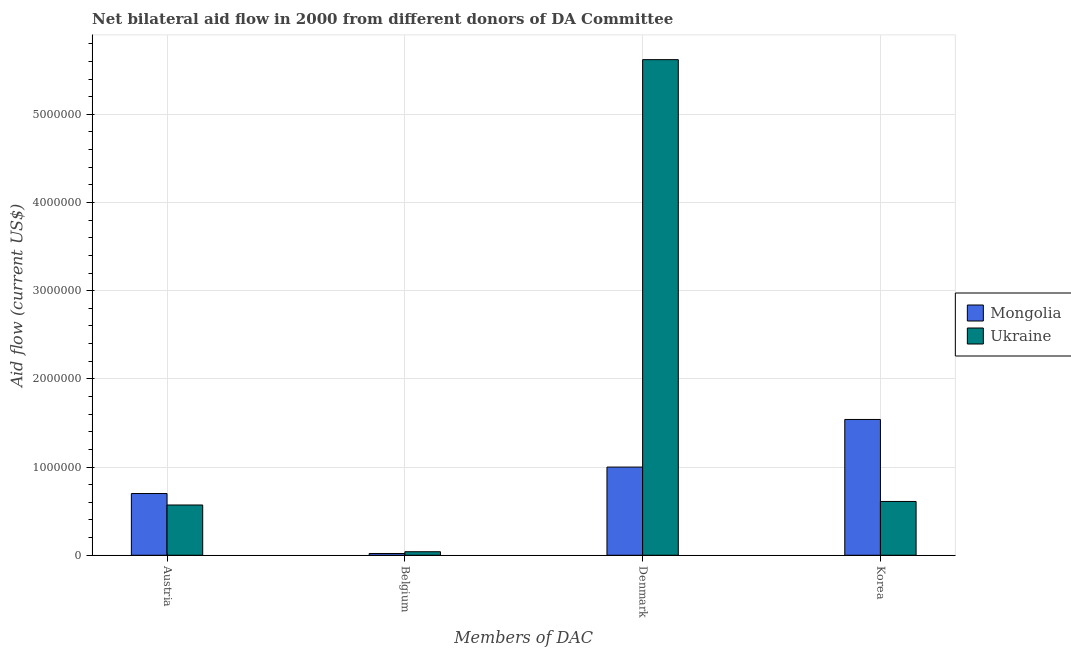Are the number of bars per tick equal to the number of legend labels?
Provide a short and direct response. Yes. How many bars are there on the 2nd tick from the left?
Your answer should be very brief. 2. How many bars are there on the 1st tick from the right?
Keep it short and to the point. 2. What is the amount of aid given by belgium in Mongolia?
Provide a short and direct response. 2.00e+04. Across all countries, what is the maximum amount of aid given by korea?
Offer a terse response. 1.54e+06. Across all countries, what is the minimum amount of aid given by austria?
Your answer should be compact. 5.70e+05. In which country was the amount of aid given by korea maximum?
Make the answer very short. Mongolia. In which country was the amount of aid given by austria minimum?
Ensure brevity in your answer.  Ukraine. What is the total amount of aid given by belgium in the graph?
Provide a succinct answer. 6.00e+04. What is the difference between the amount of aid given by denmark in Mongolia and that in Ukraine?
Provide a short and direct response. -4.62e+06. What is the difference between the amount of aid given by denmark in Ukraine and the amount of aid given by belgium in Mongolia?
Your answer should be very brief. 5.60e+06. What is the average amount of aid given by belgium per country?
Provide a short and direct response. 3.00e+04. What is the difference between the amount of aid given by denmark and amount of aid given by belgium in Ukraine?
Make the answer very short. 5.58e+06. What is the ratio of the amount of aid given by korea in Mongolia to that in Ukraine?
Your answer should be very brief. 2.52. Is the amount of aid given by belgium in Ukraine less than that in Mongolia?
Provide a succinct answer. No. What is the difference between the highest and the second highest amount of aid given by austria?
Make the answer very short. 1.30e+05. What is the difference between the highest and the lowest amount of aid given by korea?
Keep it short and to the point. 9.30e+05. Is it the case that in every country, the sum of the amount of aid given by denmark and amount of aid given by austria is greater than the sum of amount of aid given by belgium and amount of aid given by korea?
Provide a succinct answer. No. What does the 2nd bar from the left in Denmark represents?
Your answer should be compact. Ukraine. What does the 1st bar from the right in Denmark represents?
Your answer should be very brief. Ukraine. Are all the bars in the graph horizontal?
Make the answer very short. No. What is the difference between two consecutive major ticks on the Y-axis?
Your answer should be very brief. 1.00e+06. Are the values on the major ticks of Y-axis written in scientific E-notation?
Provide a succinct answer. No. Does the graph contain any zero values?
Your answer should be very brief. No. How many legend labels are there?
Your answer should be very brief. 2. What is the title of the graph?
Your answer should be compact. Net bilateral aid flow in 2000 from different donors of DA Committee. Does "Nepal" appear as one of the legend labels in the graph?
Your answer should be very brief. No. What is the label or title of the X-axis?
Provide a short and direct response. Members of DAC. What is the label or title of the Y-axis?
Provide a short and direct response. Aid flow (current US$). What is the Aid flow (current US$) of Mongolia in Austria?
Your answer should be very brief. 7.00e+05. What is the Aid flow (current US$) in Ukraine in Austria?
Provide a succinct answer. 5.70e+05. What is the Aid flow (current US$) of Ukraine in Belgium?
Offer a terse response. 4.00e+04. What is the Aid flow (current US$) in Mongolia in Denmark?
Offer a terse response. 1.00e+06. What is the Aid flow (current US$) of Ukraine in Denmark?
Provide a short and direct response. 5.62e+06. What is the Aid flow (current US$) of Mongolia in Korea?
Give a very brief answer. 1.54e+06. Across all Members of DAC, what is the maximum Aid flow (current US$) in Mongolia?
Your answer should be compact. 1.54e+06. Across all Members of DAC, what is the maximum Aid flow (current US$) of Ukraine?
Your response must be concise. 5.62e+06. Across all Members of DAC, what is the minimum Aid flow (current US$) of Ukraine?
Provide a short and direct response. 4.00e+04. What is the total Aid flow (current US$) in Mongolia in the graph?
Give a very brief answer. 3.26e+06. What is the total Aid flow (current US$) in Ukraine in the graph?
Give a very brief answer. 6.84e+06. What is the difference between the Aid flow (current US$) in Mongolia in Austria and that in Belgium?
Your answer should be compact. 6.80e+05. What is the difference between the Aid flow (current US$) of Ukraine in Austria and that in Belgium?
Provide a short and direct response. 5.30e+05. What is the difference between the Aid flow (current US$) of Ukraine in Austria and that in Denmark?
Your response must be concise. -5.05e+06. What is the difference between the Aid flow (current US$) in Mongolia in Austria and that in Korea?
Ensure brevity in your answer.  -8.40e+05. What is the difference between the Aid flow (current US$) of Mongolia in Belgium and that in Denmark?
Keep it short and to the point. -9.80e+05. What is the difference between the Aid flow (current US$) in Ukraine in Belgium and that in Denmark?
Ensure brevity in your answer.  -5.58e+06. What is the difference between the Aid flow (current US$) of Mongolia in Belgium and that in Korea?
Offer a very short reply. -1.52e+06. What is the difference between the Aid flow (current US$) in Ukraine in Belgium and that in Korea?
Give a very brief answer. -5.70e+05. What is the difference between the Aid flow (current US$) in Mongolia in Denmark and that in Korea?
Make the answer very short. -5.40e+05. What is the difference between the Aid flow (current US$) in Ukraine in Denmark and that in Korea?
Give a very brief answer. 5.01e+06. What is the difference between the Aid flow (current US$) of Mongolia in Austria and the Aid flow (current US$) of Ukraine in Belgium?
Your answer should be very brief. 6.60e+05. What is the difference between the Aid flow (current US$) of Mongolia in Austria and the Aid flow (current US$) of Ukraine in Denmark?
Give a very brief answer. -4.92e+06. What is the difference between the Aid flow (current US$) of Mongolia in Austria and the Aid flow (current US$) of Ukraine in Korea?
Make the answer very short. 9.00e+04. What is the difference between the Aid flow (current US$) of Mongolia in Belgium and the Aid flow (current US$) of Ukraine in Denmark?
Your response must be concise. -5.60e+06. What is the difference between the Aid flow (current US$) in Mongolia in Belgium and the Aid flow (current US$) in Ukraine in Korea?
Give a very brief answer. -5.90e+05. What is the average Aid flow (current US$) of Mongolia per Members of DAC?
Your answer should be very brief. 8.15e+05. What is the average Aid flow (current US$) in Ukraine per Members of DAC?
Offer a terse response. 1.71e+06. What is the difference between the Aid flow (current US$) in Mongolia and Aid flow (current US$) in Ukraine in Austria?
Offer a very short reply. 1.30e+05. What is the difference between the Aid flow (current US$) of Mongolia and Aid flow (current US$) of Ukraine in Denmark?
Provide a short and direct response. -4.62e+06. What is the difference between the Aid flow (current US$) of Mongolia and Aid flow (current US$) of Ukraine in Korea?
Keep it short and to the point. 9.30e+05. What is the ratio of the Aid flow (current US$) of Mongolia in Austria to that in Belgium?
Give a very brief answer. 35. What is the ratio of the Aid flow (current US$) in Ukraine in Austria to that in Belgium?
Ensure brevity in your answer.  14.25. What is the ratio of the Aid flow (current US$) of Mongolia in Austria to that in Denmark?
Keep it short and to the point. 0.7. What is the ratio of the Aid flow (current US$) in Ukraine in Austria to that in Denmark?
Your response must be concise. 0.1. What is the ratio of the Aid flow (current US$) in Mongolia in Austria to that in Korea?
Offer a very short reply. 0.45. What is the ratio of the Aid flow (current US$) in Ukraine in Austria to that in Korea?
Ensure brevity in your answer.  0.93. What is the ratio of the Aid flow (current US$) of Mongolia in Belgium to that in Denmark?
Provide a short and direct response. 0.02. What is the ratio of the Aid flow (current US$) in Ukraine in Belgium to that in Denmark?
Make the answer very short. 0.01. What is the ratio of the Aid flow (current US$) of Mongolia in Belgium to that in Korea?
Keep it short and to the point. 0.01. What is the ratio of the Aid flow (current US$) in Ukraine in Belgium to that in Korea?
Ensure brevity in your answer.  0.07. What is the ratio of the Aid flow (current US$) in Mongolia in Denmark to that in Korea?
Your response must be concise. 0.65. What is the ratio of the Aid flow (current US$) in Ukraine in Denmark to that in Korea?
Provide a short and direct response. 9.21. What is the difference between the highest and the second highest Aid flow (current US$) of Mongolia?
Your response must be concise. 5.40e+05. What is the difference between the highest and the second highest Aid flow (current US$) of Ukraine?
Ensure brevity in your answer.  5.01e+06. What is the difference between the highest and the lowest Aid flow (current US$) of Mongolia?
Provide a short and direct response. 1.52e+06. What is the difference between the highest and the lowest Aid flow (current US$) of Ukraine?
Make the answer very short. 5.58e+06. 